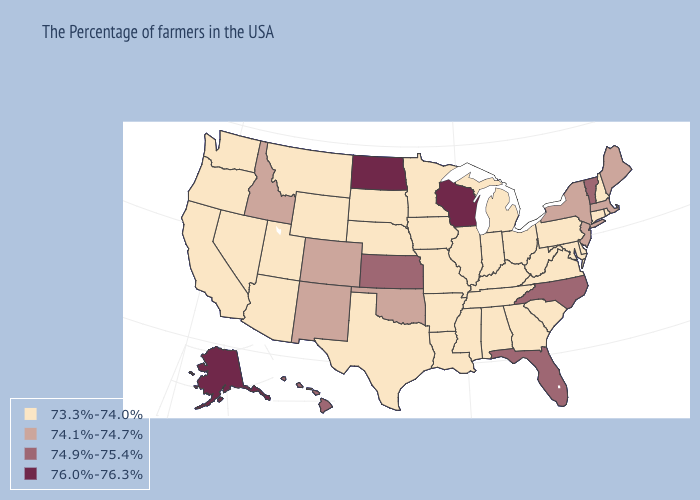Among the states that border Oregon , does Idaho have the highest value?
Give a very brief answer. Yes. What is the value of Illinois?
Be succinct. 73.3%-74.0%. Does Wisconsin have the highest value in the USA?
Keep it brief. Yes. What is the highest value in the USA?
Give a very brief answer. 76.0%-76.3%. Name the states that have a value in the range 76.0%-76.3%?
Concise answer only. Wisconsin, North Dakota, Alaska. Is the legend a continuous bar?
Answer briefly. No. What is the value of Arkansas?
Write a very short answer. 73.3%-74.0%. Does the map have missing data?
Give a very brief answer. No. Does Kentucky have a lower value than South Carolina?
Be succinct. No. Which states have the lowest value in the MidWest?
Concise answer only. Ohio, Michigan, Indiana, Illinois, Missouri, Minnesota, Iowa, Nebraska, South Dakota. Name the states that have a value in the range 74.9%-75.4%?
Keep it brief. Vermont, North Carolina, Florida, Kansas, Hawaii. Name the states that have a value in the range 73.3%-74.0%?
Give a very brief answer. Rhode Island, New Hampshire, Connecticut, Delaware, Maryland, Pennsylvania, Virginia, South Carolina, West Virginia, Ohio, Georgia, Michigan, Kentucky, Indiana, Alabama, Tennessee, Illinois, Mississippi, Louisiana, Missouri, Arkansas, Minnesota, Iowa, Nebraska, Texas, South Dakota, Wyoming, Utah, Montana, Arizona, Nevada, California, Washington, Oregon. What is the highest value in the USA?
Quick response, please. 76.0%-76.3%. Does Kansas have the lowest value in the MidWest?
Quick response, please. No. 